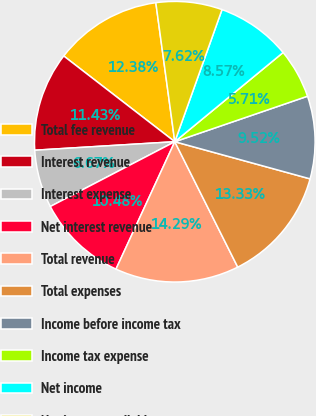<chart> <loc_0><loc_0><loc_500><loc_500><pie_chart><fcel>Total fee revenue<fcel>Interest revenue<fcel>Interest expense<fcel>Net interest revenue<fcel>Total revenue<fcel>Total expenses<fcel>Income before income tax<fcel>Income tax expense<fcel>Net income<fcel>Net income available to common<nl><fcel>12.38%<fcel>11.43%<fcel>6.67%<fcel>10.48%<fcel>14.29%<fcel>13.33%<fcel>9.52%<fcel>5.71%<fcel>8.57%<fcel>7.62%<nl></chart> 